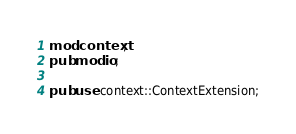<code> <loc_0><loc_0><loc_500><loc_500><_Rust_>mod context;
pub mod io;

pub use context::ContextExtension;
</code> 